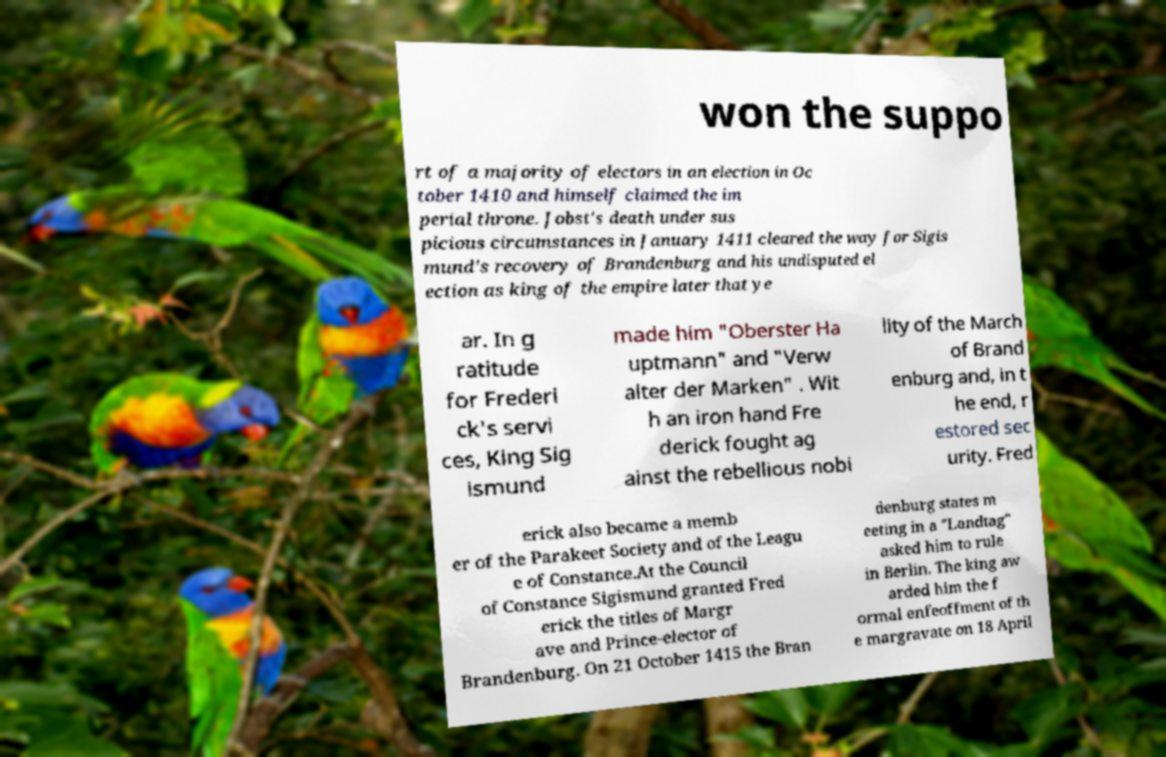Could you extract and type out the text from this image? won the suppo rt of a majority of electors in an election in Oc tober 1410 and himself claimed the im perial throne. Jobst's death under sus picious circumstances in January 1411 cleared the way for Sigis mund's recovery of Brandenburg and his undisputed el ection as king of the empire later that ye ar. In g ratitude for Frederi ck's servi ces, King Sig ismund made him "Oberster Ha uptmann" and "Verw alter der Marken" . Wit h an iron hand Fre derick fought ag ainst the rebellious nobi lity of the March of Brand enburg and, in t he end, r estored sec urity. Fred erick also became a memb er of the Parakeet Society and of the Leagu e of Constance.At the Council of Constance Sigismund granted Fred erick the titles of Margr ave and Prince-elector of Brandenburg. On 21 October 1415 the Bran denburg states m eeting in a "Landtag" asked him to rule in Berlin. The king aw arded him the f ormal enfeoffment of th e margravate on 18 April 